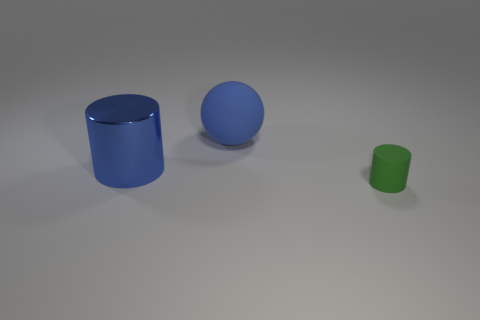Add 3 small red rubber blocks. How many objects exist? 6 Subtract all spheres. How many objects are left? 2 Subtract 1 spheres. How many spheres are left? 0 Add 3 blue metallic cylinders. How many blue metallic cylinders exist? 4 Subtract all blue cylinders. How many cylinders are left? 1 Subtract 0 yellow cylinders. How many objects are left? 3 Subtract all blue cylinders. Subtract all gray balls. How many cylinders are left? 1 Subtract all purple balls. How many blue cylinders are left? 1 Subtract all small rubber objects. Subtract all spheres. How many objects are left? 1 Add 1 tiny green matte things. How many tiny green matte things are left? 2 